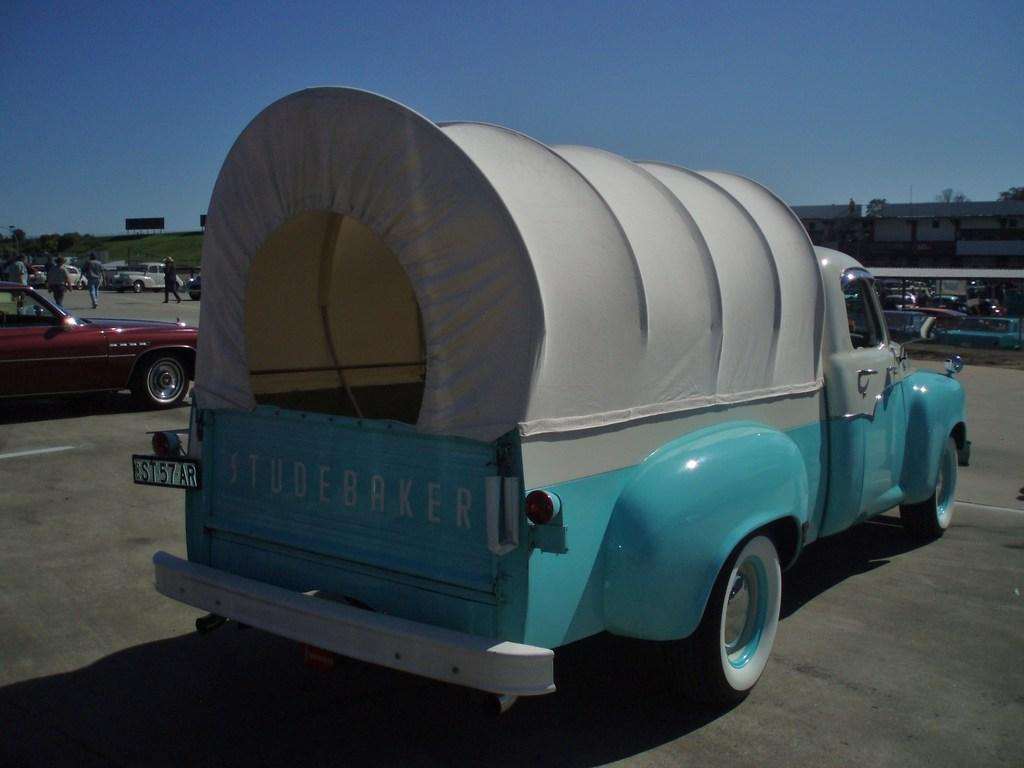What types of objects can be seen in the image? There are vehicles, people, buildings, poles, trees, a board, and a shed in the image. Can you describe the setting of the image? The image features a combination of urban and natural elements, including buildings, trees, and a shed. What is visible in the background of the image? The sky is visible in the background of the image. What might be used for displaying information or advertisements in the image? The board in the image might be used for displaying information or advertisements. What type of alarm can be heard going off in the image? There is no alarm present in the image, and therefore no such sound can be heard. What is the neck of the person in the image doing? There is no person's neck visible in the image, as the focus is on the various objects and structures. 